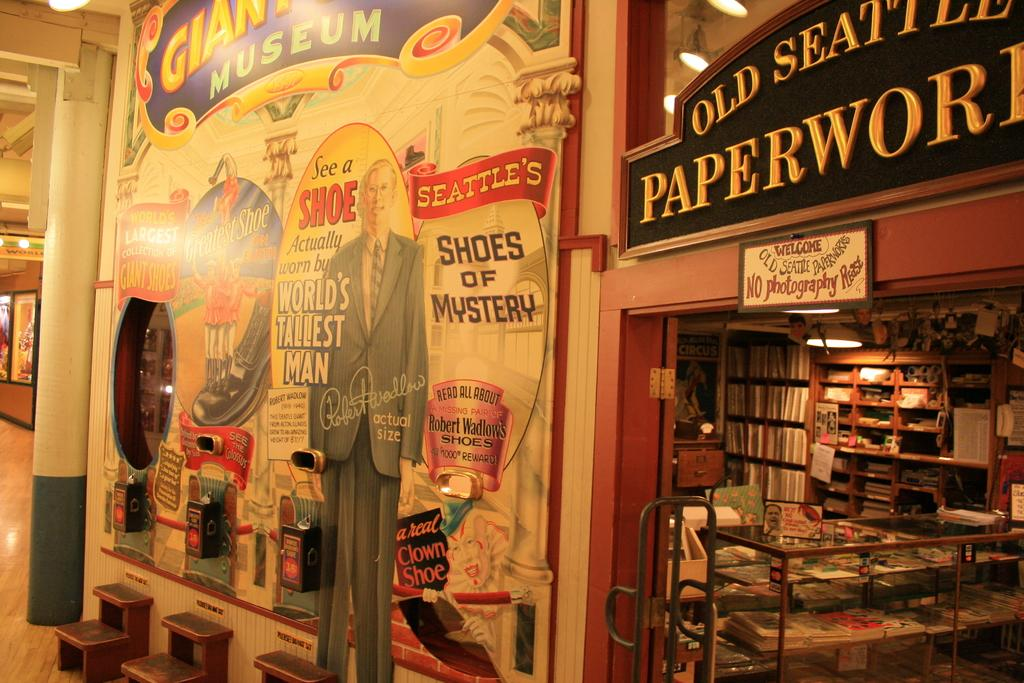<image>
Share a concise interpretation of the image provided. Store front that says Old Seattle Paperwork on top. 